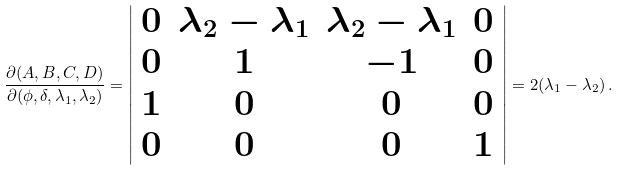<formula> <loc_0><loc_0><loc_500><loc_500>\frac { \partial ( A , B , C , D ) } { \partial ( \phi , \delta , \lambda _ { 1 } , \lambda _ { 2 } ) } = \left | \begin{array} { c c c c c } 0 & \lambda _ { 2 } - \lambda _ { 1 } & \lambda _ { 2 } - \lambda _ { 1 } & 0 \\ 0 & 1 & - 1 & 0 \\ 1 & 0 & 0 & 0 \\ 0 & 0 & 0 & 1 \end{array} \right | = 2 ( \lambda _ { 1 } - \lambda _ { 2 } ) \, .</formula> 